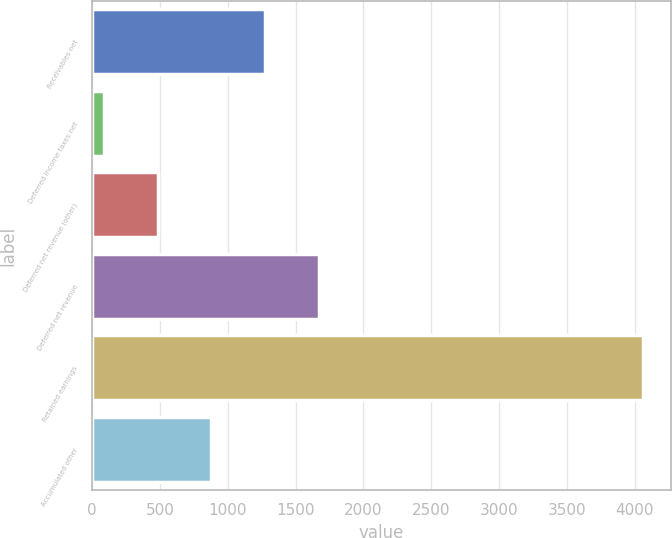Convert chart. <chart><loc_0><loc_0><loc_500><loc_500><bar_chart><fcel>Receivables net<fcel>Deferred income taxes net<fcel>Deferred net revenue (other)<fcel>Deferred net revenue<fcel>Retained earnings<fcel>Accumulated other<nl><fcel>1277.4<fcel>84<fcel>481.8<fcel>1675.2<fcel>4062<fcel>879.6<nl></chart> 